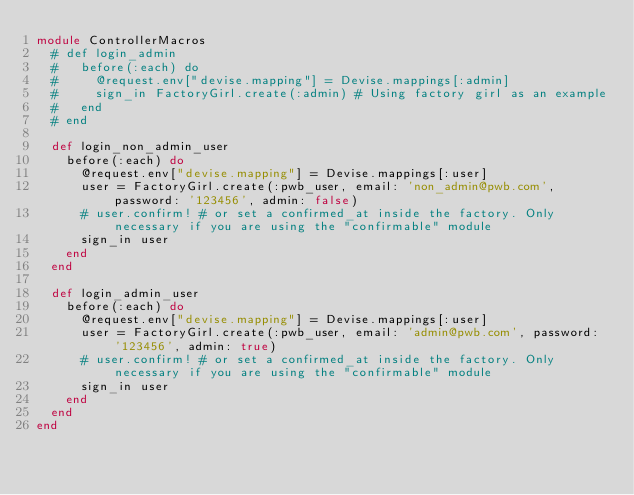Convert code to text. <code><loc_0><loc_0><loc_500><loc_500><_Ruby_>module ControllerMacros
  # def login_admin
  #   before(:each) do
  #     @request.env["devise.mapping"] = Devise.mappings[:admin]
  #     sign_in FactoryGirl.create(:admin) # Using factory girl as an example
  #   end
  # end

  def login_non_admin_user
    before(:each) do
      @request.env["devise.mapping"] = Devise.mappings[:user]
      user = FactoryGirl.create(:pwb_user, email: 'non_admin@pwb.com', password: '123456', admin: false)
      # user.confirm! # or set a confirmed_at inside the factory. Only necessary if you are using the "confirmable" module
      sign_in user
    end
  end

  def login_admin_user
    before(:each) do
      @request.env["devise.mapping"] = Devise.mappings[:user]
      user = FactoryGirl.create(:pwb_user, email: 'admin@pwb.com', password: '123456', admin: true)
      # user.confirm! # or set a confirmed_at inside the factory. Only necessary if you are using the "confirmable" module
      sign_in user
    end
  end
end
</code> 